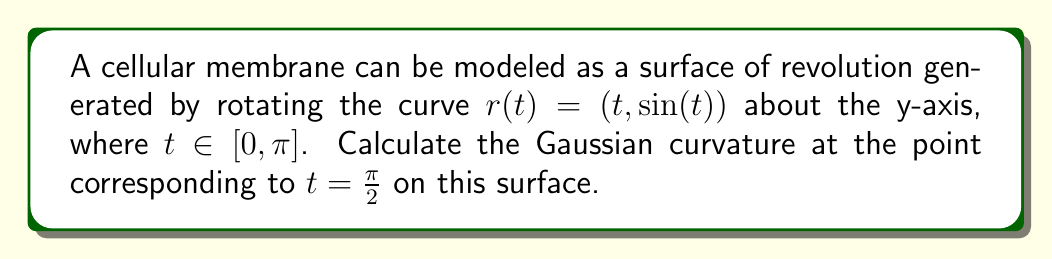Show me your answer to this math problem. To find the Gaussian curvature, we'll follow these steps:

1) First, we need to parametrize the surface. The parametric equations for a surface of revolution around the y-axis are:

   $$x = f(t)\cos(\theta)$$
   $$y = g(t)$$
   $$z = f(t)\sin(\theta)$$

   Where $(f(t), g(t))$ is the generating curve. In our case:
   
   $$f(t) = t$$
   $$g(t) = \sin(t)$$

2) The Gaussian curvature K is given by:

   $$K = \frac{f''(t)(f'(t)^2 + g'(t)^2) - f'(t)g'(t)g''(t)}{f(t)(f'(t)^2 + g'(t)^2)^2}$$

3) Let's calculate the derivatives:

   $$f'(t) = 1$$
   $$f''(t) = 0$$
   $$g'(t) = \cos(t)$$
   $$g''(t) = -\sin(t)$$

4) Substituting these into the formula for K:

   $$K = \frac{0(1^2 + \cos^2(t)) - 1 \cdot \cos(t) \cdot (-\sin(t))}{t(1^2 + \cos^2(t))^2}$$

5) Simplifying:

   $$K = \frac{\sin(t)\cos(t)}{t(1 + \cos^2(t))^2}$$

6) Now, we need to evaluate this at $t = \frac{\pi}{2}$:

   $$K_{t=\frac{\pi}{2}} = \frac{\sin(\frac{\pi}{2})\cos(\frac{\pi}{2})}{\frac{\pi}{2}(1 + \cos^2(\frac{\pi}{2}))^2}$$

7) Simplify:
   
   $$K_{t=\frac{\pi}{2}} = \frac{1 \cdot 0}{\frac{\pi}{2}(1 + 0^2)^2} = 0$$

Therefore, the Gaussian curvature at $t = \frac{\pi}{2}$ is 0.
Answer: 0 